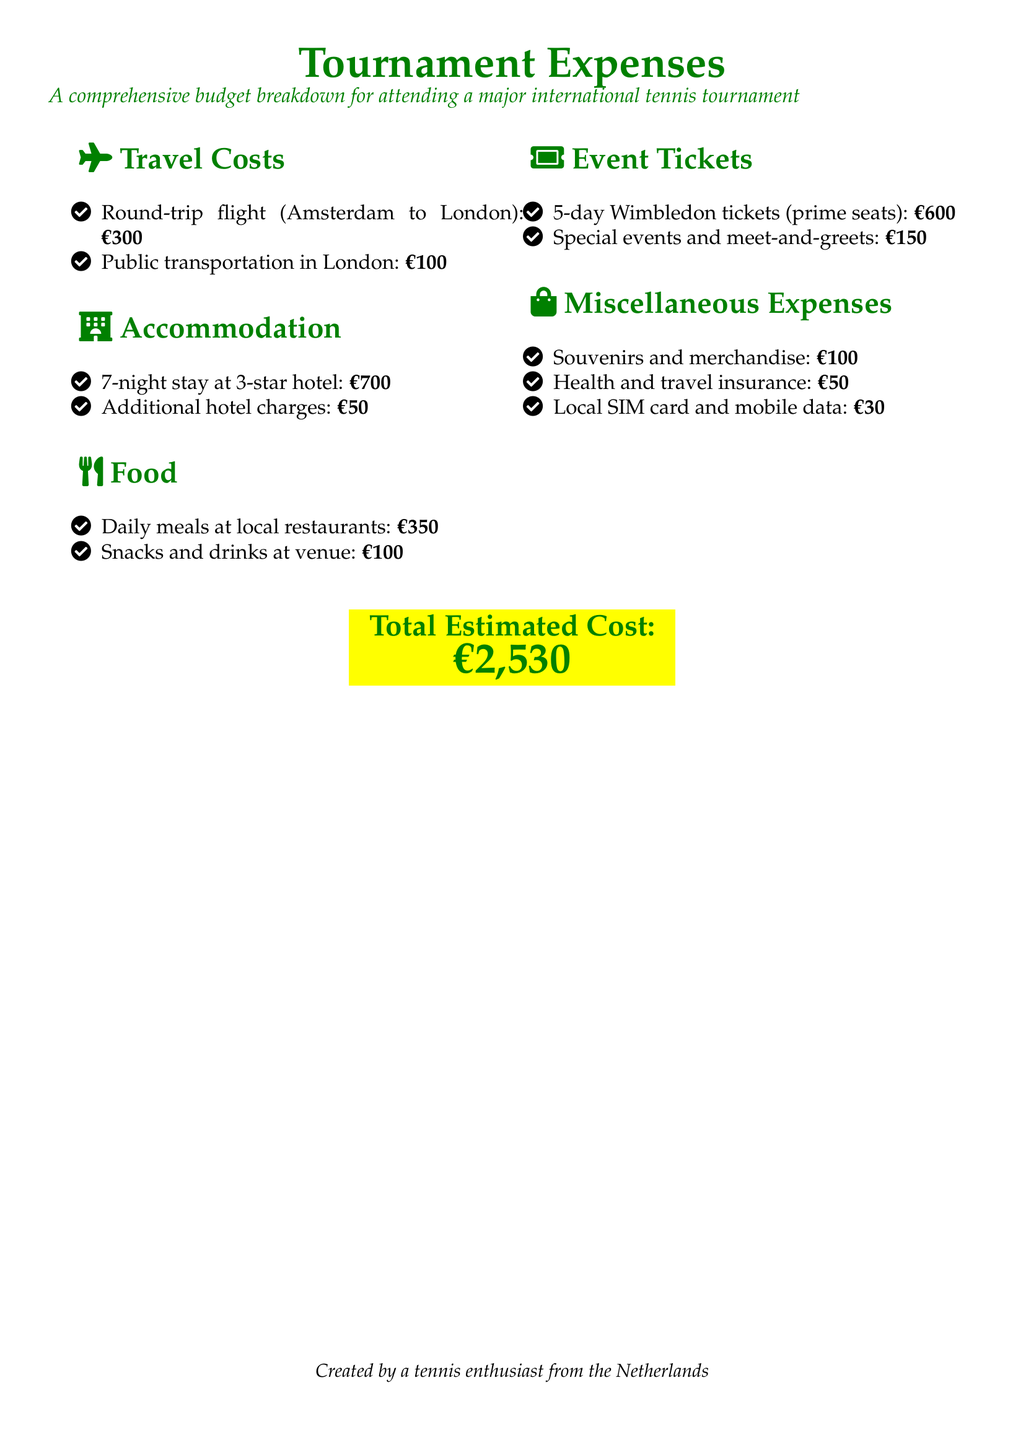what is the total estimated cost? The total estimated cost is stated prominently at the bottom of the document.
Answer: €2,530 how much for the round-trip flight from Amsterdam to London? The round-trip flight cost is listed under Travel Costs as part of the budget breakdown.
Answer: €300 what are the additional hotel charges? Additional hotel charges are specified in the Accommodation section of the document.
Answer: €50 how many nights is the hotel stay? This information is provided in the Accommodation section, detailing the stay duration.
Answer: 7 nights what is the cost of the 5-day Wimbledon tickets? The price of the 5-day Wimbledon tickets is mentioned in the Event Tickets section.
Answer: €600 how much is allocated for local SIM card and mobile data? This expense is included in the Miscellaneous Expenses section of the budget breakdown.
Answer: €30 what is the total food expense? The total food expense derives from summing the values listed in the Food section.
Answer: €450 how much is spent on souvenirs and merchandise? The amount for souvenirs and merchandise is specified in the Miscellaneous Expenses list.
Answer: €100 what category does the health and travel insurance expense fall under? This expense type is categorized in the Miscellaneous Expenses section of the document.
Answer: Miscellaneous Expenses 